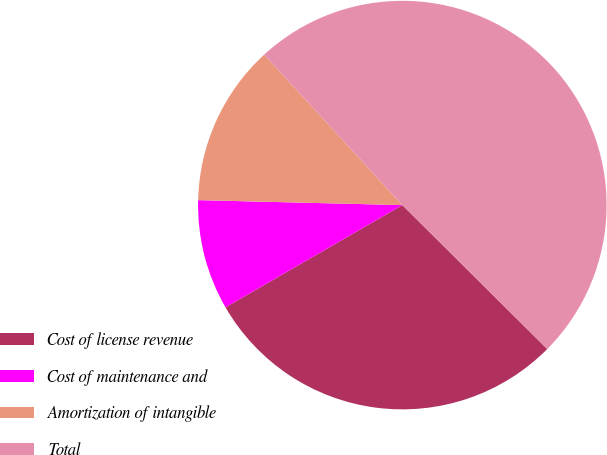Convert chart to OTSL. <chart><loc_0><loc_0><loc_500><loc_500><pie_chart><fcel>Cost of license revenue<fcel>Cost of maintenance and<fcel>Amortization of intangible<fcel>Total<nl><fcel>29.21%<fcel>8.73%<fcel>12.79%<fcel>49.27%<nl></chart> 